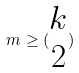<formula> <loc_0><loc_0><loc_500><loc_500>m \geq ( \begin{matrix} k \\ 2 \end{matrix} )</formula> 